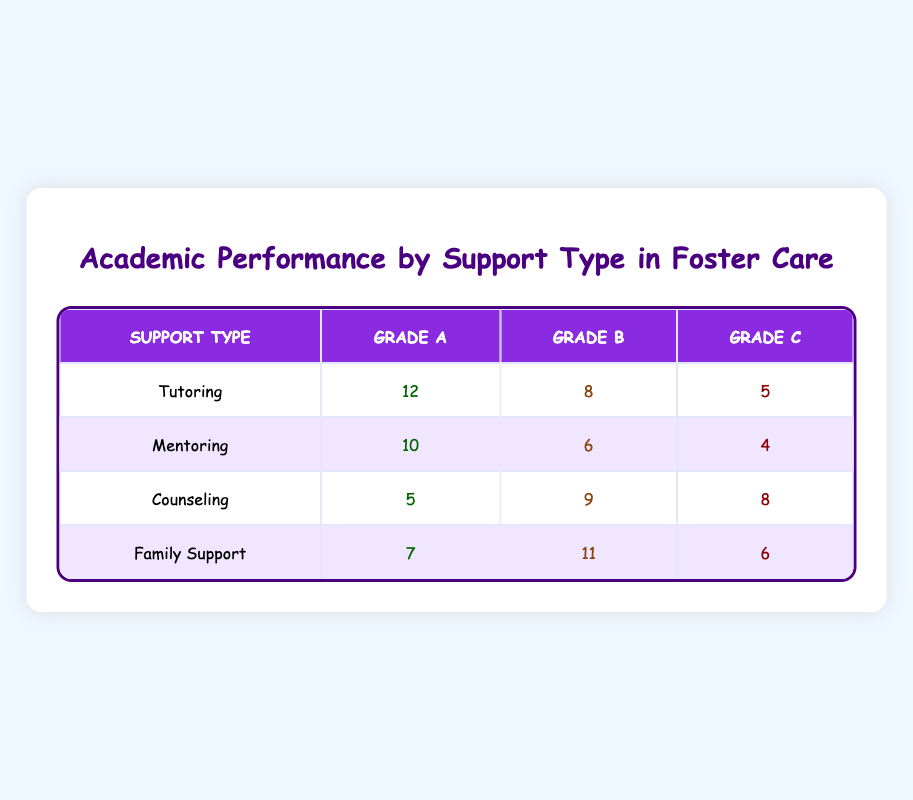What is the highest count of Grade A performance among the support types? The highest count for Grade A performance can be found by looking across the rows under the "Grade A" column. Tutoring has a count of 12, Mentoring has 10, Counseling has 5, and Family Support has 7. Therefore, the highest count is 12 from Tutoring.
Answer: 12 Which support type has the lowest total count across all grades? To find this, we sum the counts for each support type. Tutoring: 12 + 8 + 5 = 25; Mentoring: 10 + 6 + 4 = 20; Counseling: 5 + 9 + 8 = 22; Family Support: 7 + 11 + 6 = 24. The lowest total is for Mentoring, which is 20.
Answer: Mentoring Is it true that Counseling has more Grade B than Grade C performance? Looking at the counts for Counseling, Grade B has 9 and Grade C has 8. Since 9 is greater than 8, the statement is true.
Answer: Yes What is the average count of Grade C performance across the support types? To calculate the average, we first sum the Grade C counts: 5 (Tutoring) + 4 (Mentoring) + 8 (Counseling) + 6 (Family Support) = 23. We then divide by the number of support types, which is 4. Therefore, the average is 23/4 = 5.75.
Answer: 5.75 Which support type has the highest count in Grade B and what is that count? By checking the "Grade B" column, we see Tutoring has 8, Mentoring has 6, Counseling has 9, and Family Support has 11. The highest count in Grade B is 11 from Family Support.
Answer: Family Support, 11 What is the total count for all Grade A performances? To find the total for Grade A, we add the counts: 12 (Tutoring) + 10 (Mentoring) + 5 (Counseling) + 7 (Family Support) = 34. Therefore, the total count for all Grade A performances is 34.
Answer: 34 Is the count of Grade C for Tutoring greater than that of Family Support? Looking at the counts, Tutoring has 5 in Grade C, and Family Support has 6 in Grade C. Since 5 is not greater than 6, the statement is false.
Answer: No What is the difference between the counts of Grade A and Grade C for Family Support? For Family Support, the count of Grade A is 7 and Grade C is 6. We find the difference by subtracting: 7 (Grade A) - 6 (Grade C) = 1.
Answer: 1 